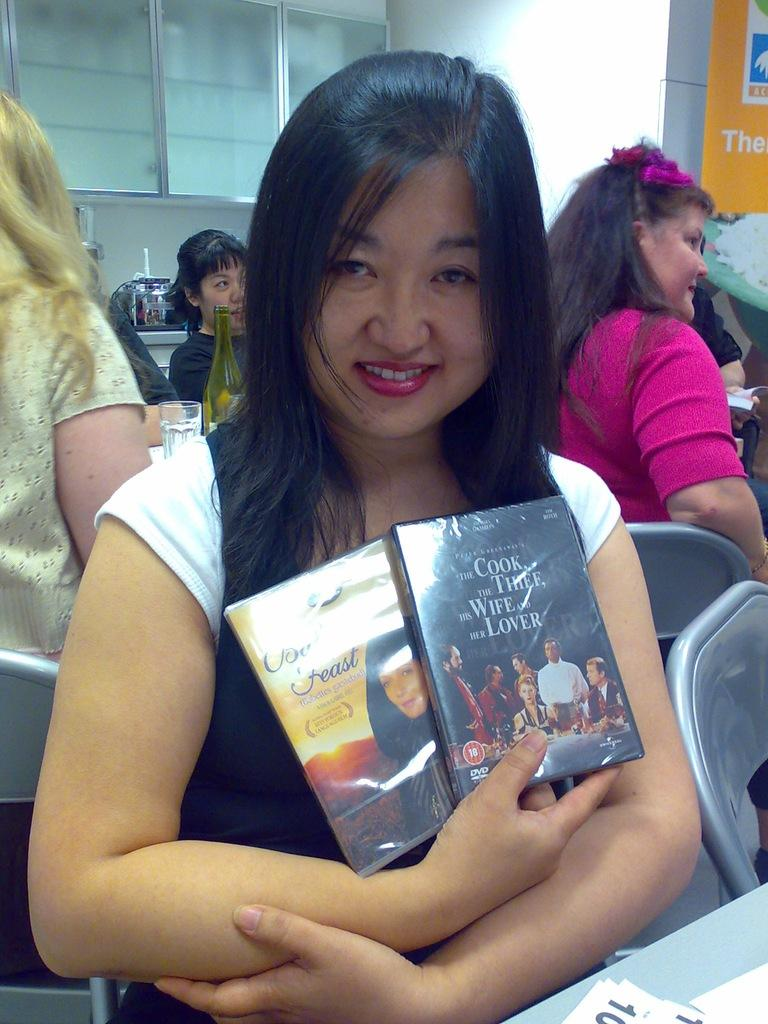<image>
Write a terse but informative summary of the picture. A woman holding two DVDs, one is The Cook the Thief his Wife and her Lover. 